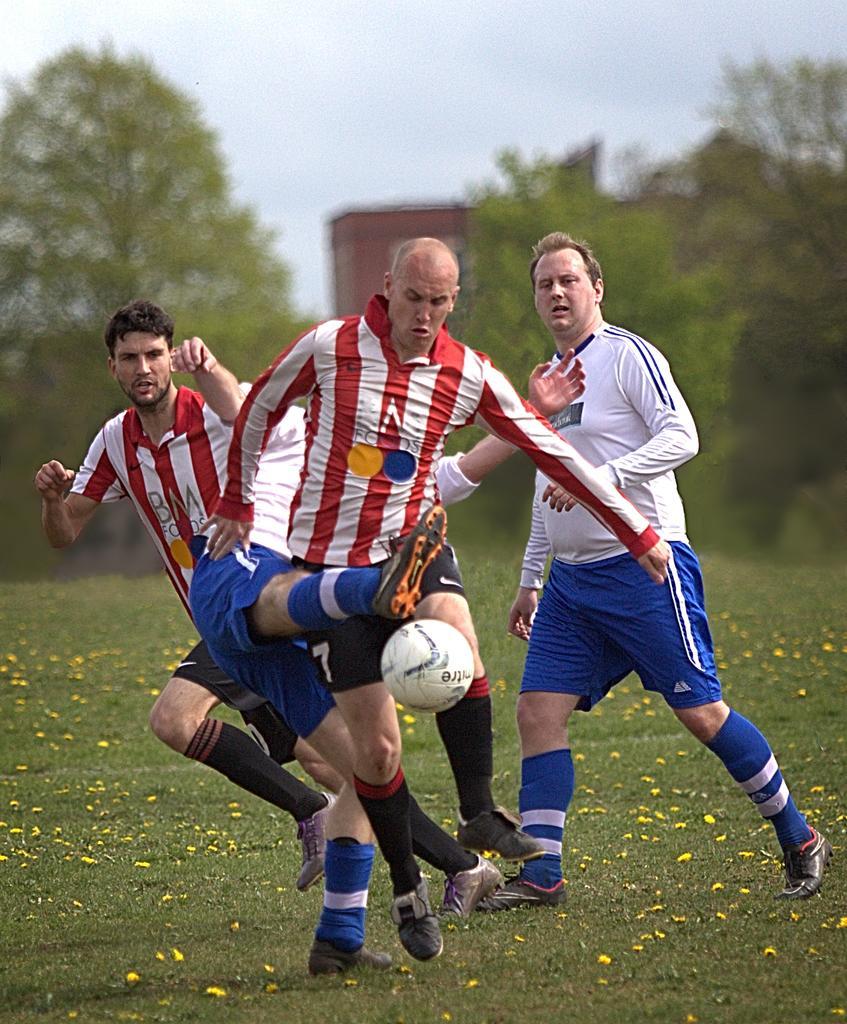Could you give a brief overview of what you see in this image? In this image there are people running on the grassland. A ball is in the air. Background there are trees. Behind there is a building. Top of the image there is sky. Right side there is a person walking on the grassland. 